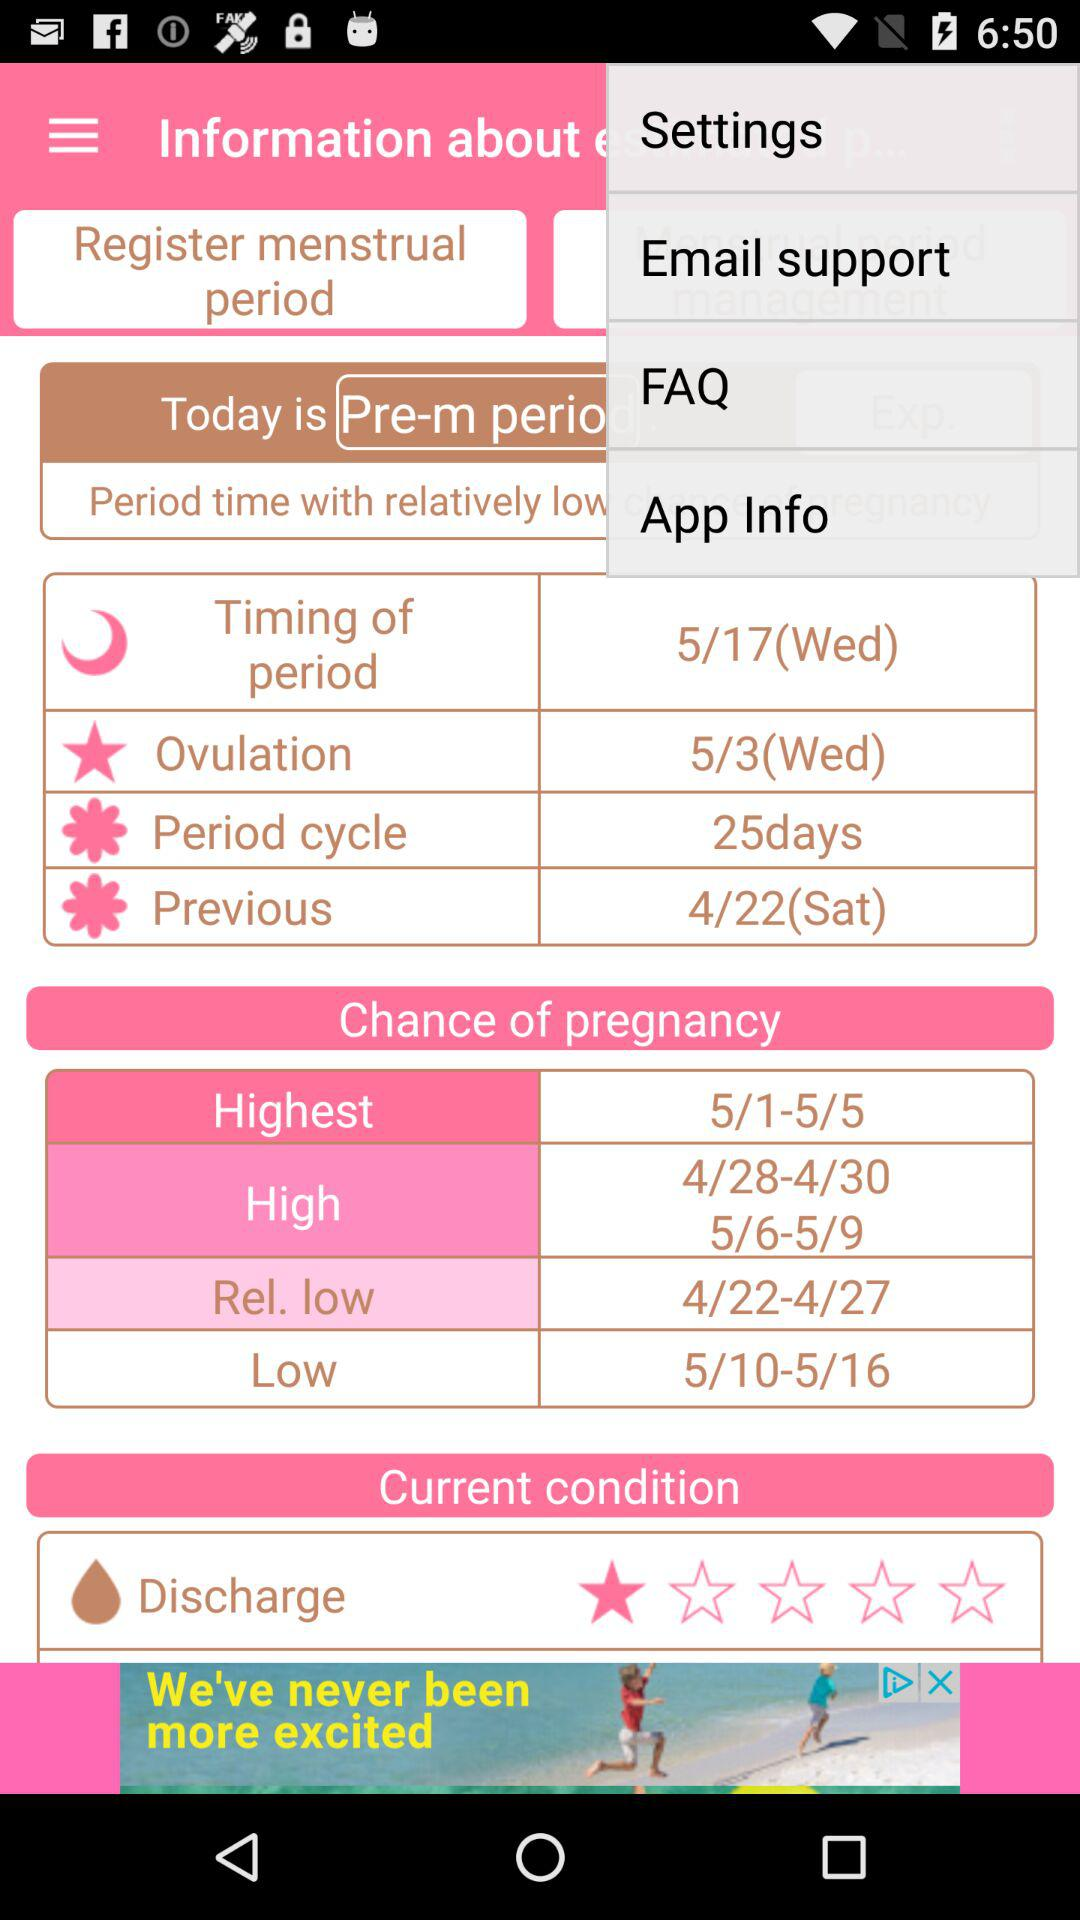What is the discharge rating? The discharge rating is 1 star. 